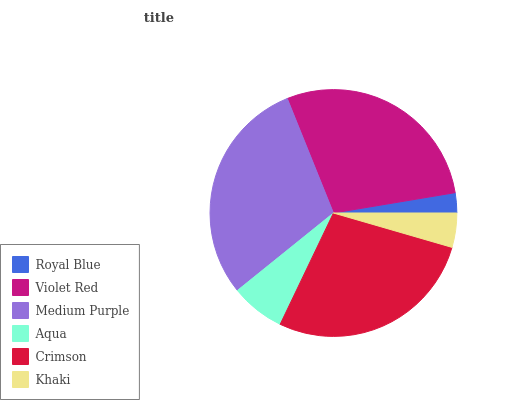Is Royal Blue the minimum?
Answer yes or no. Yes. Is Medium Purple the maximum?
Answer yes or no. Yes. Is Violet Red the minimum?
Answer yes or no. No. Is Violet Red the maximum?
Answer yes or no. No. Is Violet Red greater than Royal Blue?
Answer yes or no. Yes. Is Royal Blue less than Violet Red?
Answer yes or no. Yes. Is Royal Blue greater than Violet Red?
Answer yes or no. No. Is Violet Red less than Royal Blue?
Answer yes or no. No. Is Crimson the high median?
Answer yes or no. Yes. Is Aqua the low median?
Answer yes or no. Yes. Is Aqua the high median?
Answer yes or no. No. Is Violet Red the low median?
Answer yes or no. No. 